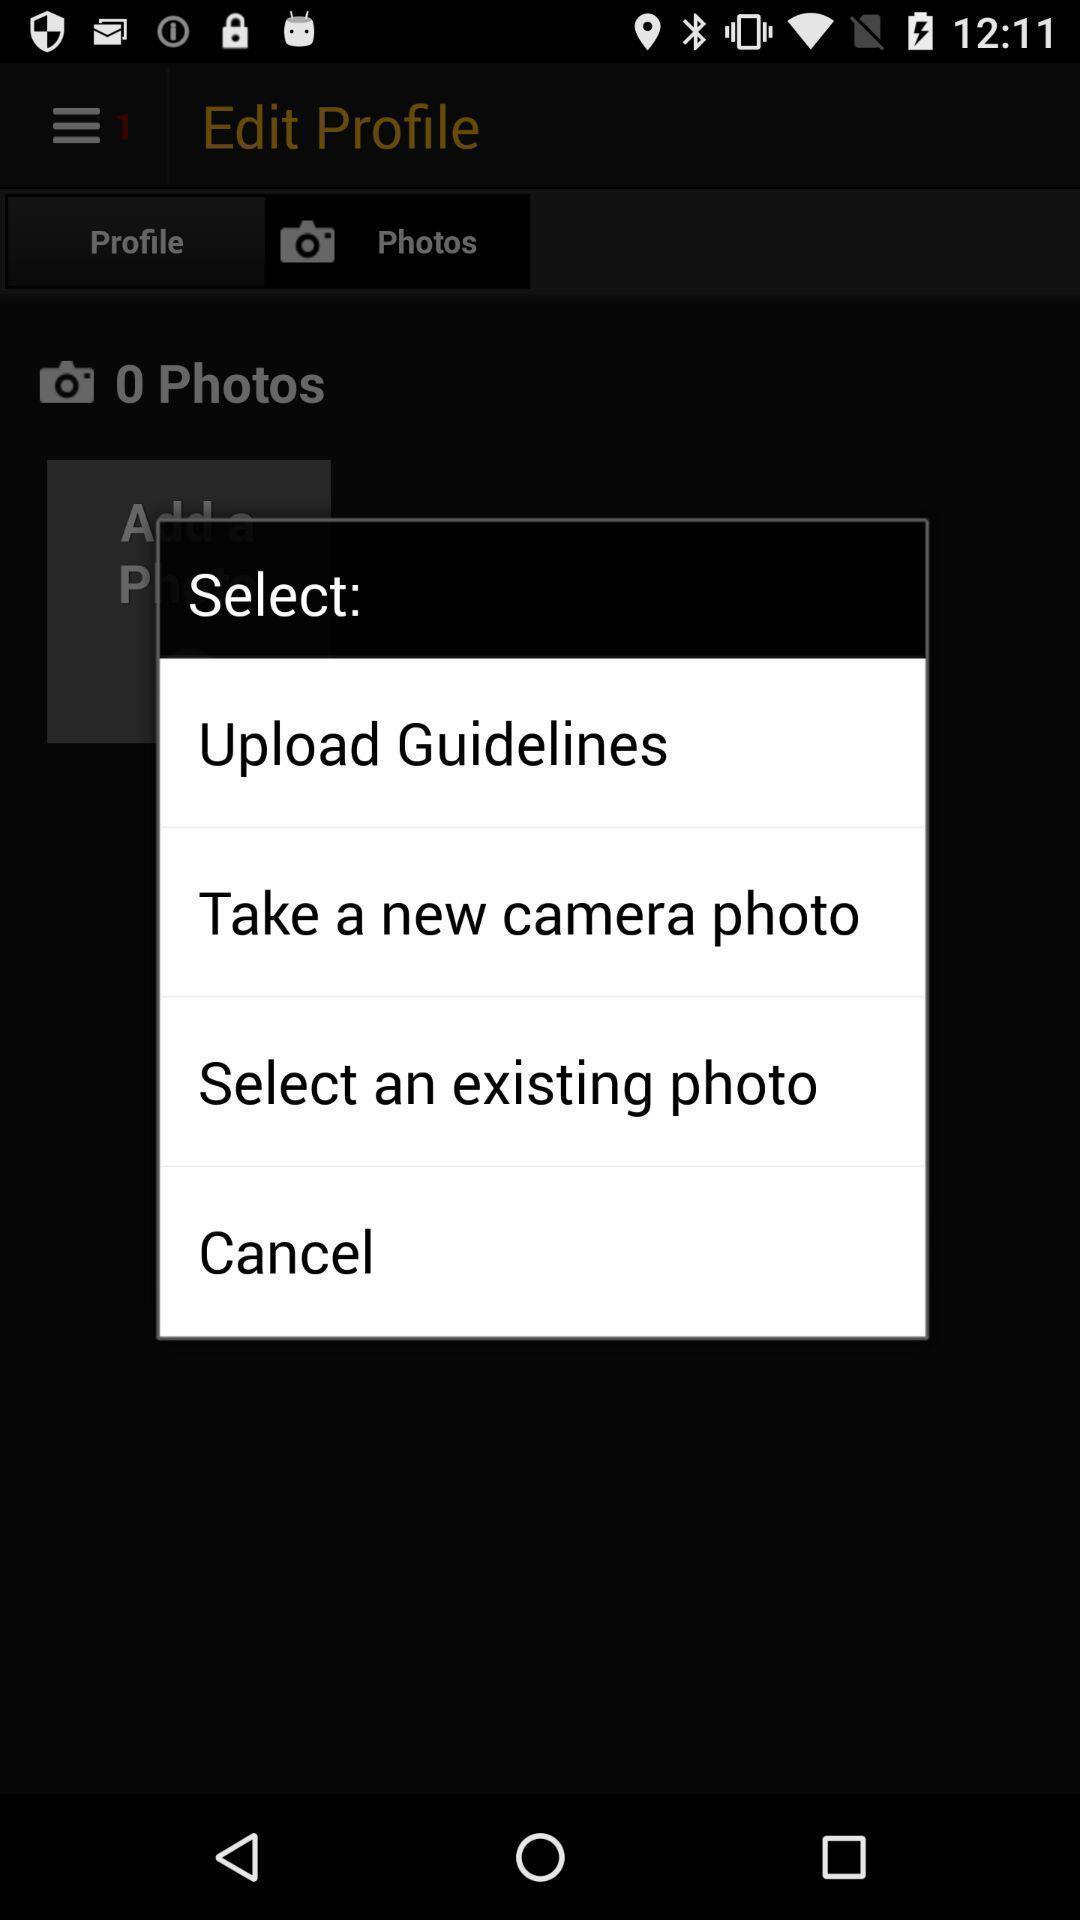What details can you identify in this image? Pop-up shows select options. 